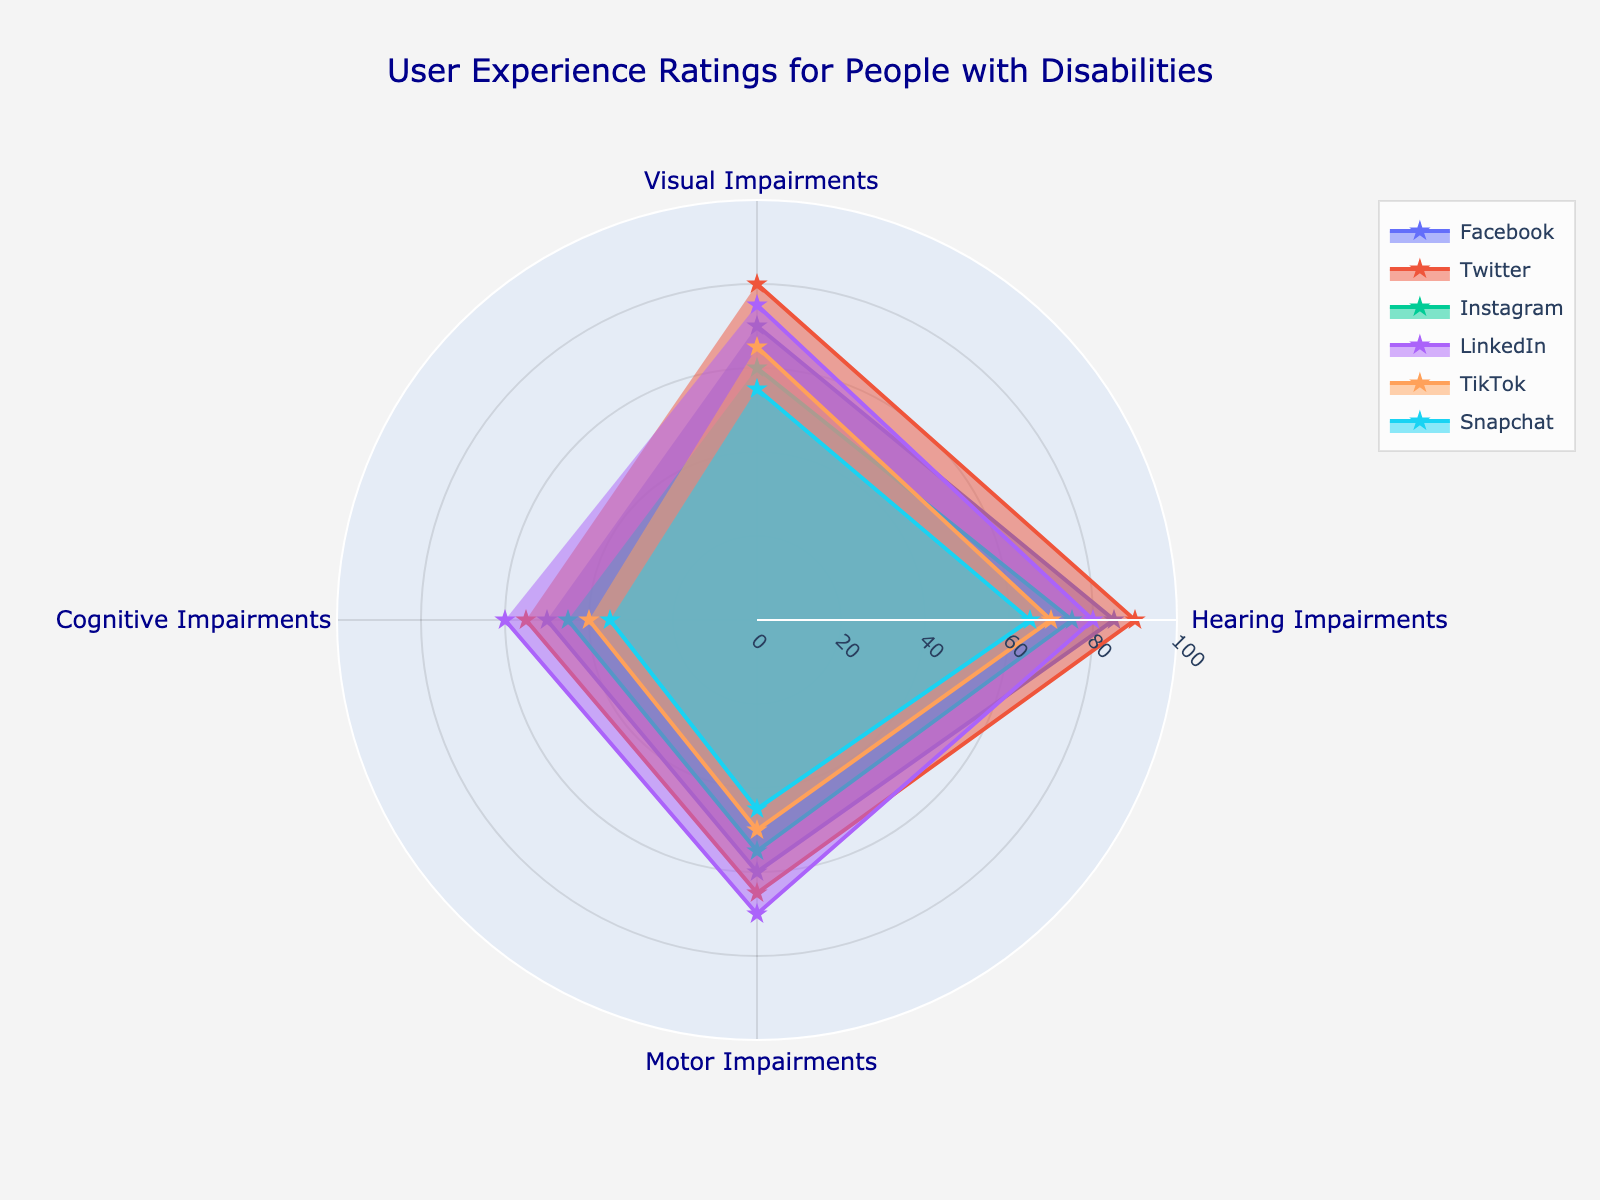Which platform has the highest rating for visual impairments? By visually inspecting the radial plot for visual impairments, the platform with the largest value on this axis is Twitter.
Answer: Twitter What is the average rating for cognitive impairments across all platforms? Sum the cognitive impairments ratings: 50 (Facebook) + 55 (Twitter) + 45 (Instagram) + 60 (LinkedIn) + 40 (TikTok) + 35 (Snapchat) = 285. Divide by the number of platforms (6): 285/6 = 47.5.
Answer: 47.5 Which platform shows the lowest rating for any type of impairment, and which impairment is it? The lowest rating on the radial chart is 35 for cognitive impairments on Snapchat.
Answer: Snapchat and cognitive impairments Compare LinkedIn and TikTok ratings for hearing impairments. Which platform scores higher and by how much? LinkedIn's rating for hearing impairments is 80, and TikTok's rating is 70. The difference is 80 - 70 = 10.
Answer: LinkedIn by 10 What is the range of ratings for motor impairments across all platforms? The highest motor impairments rating is LinkedIn (70), and the lowest is Snapchat (45). The range is 70 - 45 = 25.
Answer: 25 Which category has the most variation in ratings across all platforms? By visually inspecting the spread of values for each category, cognitive impairments have the widest range of ratings (35 to 60).
Answer: Cognitive impairments Which social media platform has the most balanced (least variation) user experience ratings across all impairments? By visually comparing the spread of values within each platform, LinkedIn has the least variation with ratings between 60 and 80.
Answer: LinkedIn For visual impairments, how much lower is Instagram's rating compared to Facebook's rating? Facebook's visual impairment rating is 70, and Instagram's is 60. The difference is 70 - 60 = 10.
Answer: 10 What is the median rating for motor impairments across all platforms? The motor impairments ratings are 60 (Facebook), 65 (Twitter), 55 (Instagram), 70 (LinkedIn), 50 (TikTok), and 45 (Snapchat). Sorting them: 45, 50, 55, 60, 65, 70. The median is (55+60)/2 = 57.5.
Answer: 57.5 